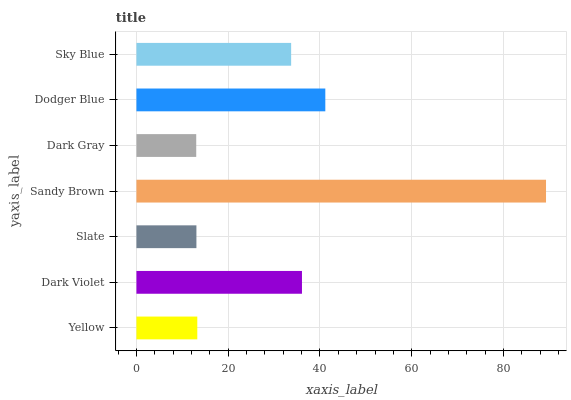Is Dark Gray the minimum?
Answer yes or no. Yes. Is Sandy Brown the maximum?
Answer yes or no. Yes. Is Dark Violet the minimum?
Answer yes or no. No. Is Dark Violet the maximum?
Answer yes or no. No. Is Dark Violet greater than Yellow?
Answer yes or no. Yes. Is Yellow less than Dark Violet?
Answer yes or no. Yes. Is Yellow greater than Dark Violet?
Answer yes or no. No. Is Dark Violet less than Yellow?
Answer yes or no. No. Is Sky Blue the high median?
Answer yes or no. Yes. Is Sky Blue the low median?
Answer yes or no. Yes. Is Yellow the high median?
Answer yes or no. No. Is Yellow the low median?
Answer yes or no. No. 